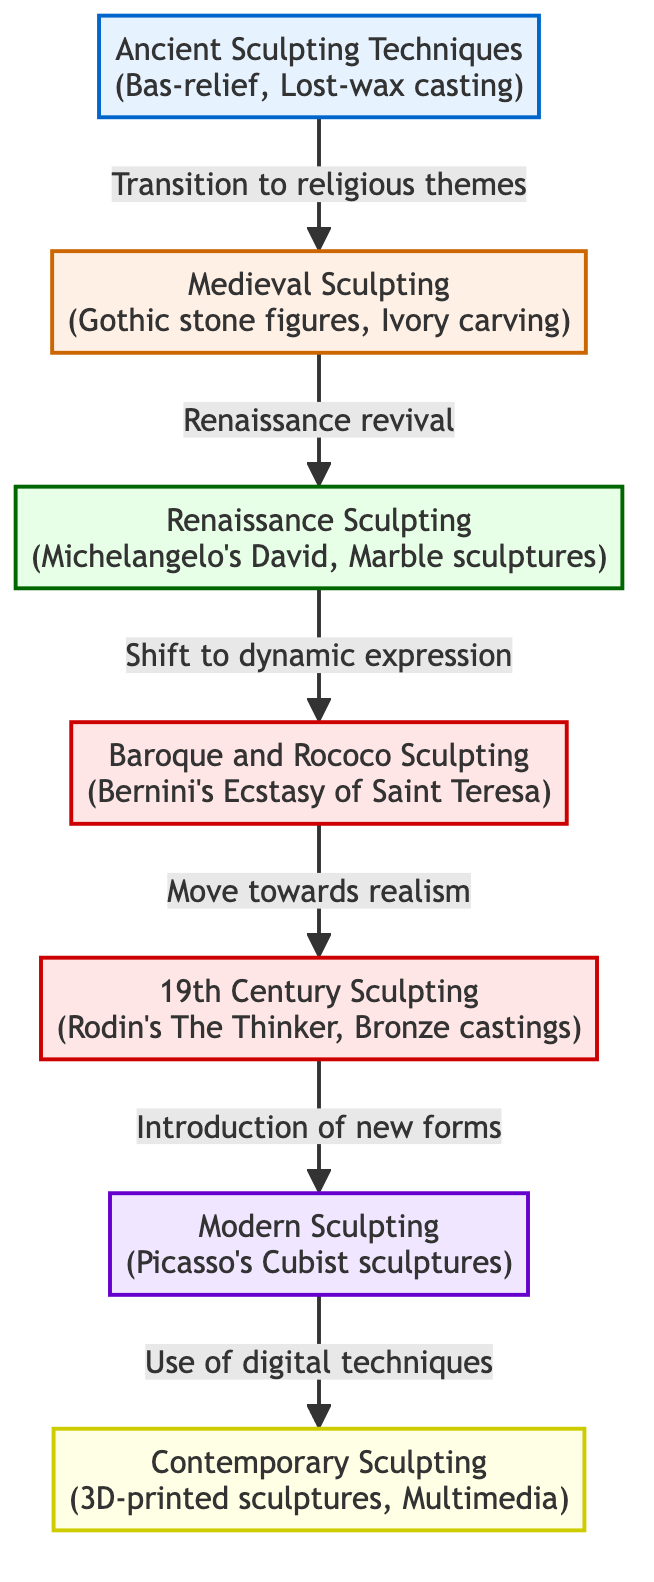What are the ancient sculpting techniques listed in the diagram? The diagram shows "Bas-relief" and "Lost-wax casting" under the ancient sculpting techniques node.
Answer: Bas-relief, Lost-wax casting Which sculpting technique is associated with Michelangelo? Michelangelo is prominently associated with "Michelangelo's David" under the Renaissance sculpting techniques.
Answer: Michelangelo's David How many distinct eras of sculpting techniques are included in the diagram? Counting each node from ancient, medieval, renaissance, baroque, modern, to contemporary, there are a total of 7 distinct eras listed.
Answer: 7 Which sculpting technique signifies the transition from Medieval to Renaissance? The transition is indicated by the phrase "Renaissance revival" connecting the nodes of Medieval and Renaissance sculpting.
Answer: Renaissance revival What is the last listed sculpting technique in the diagram? The final node in the diagram details "3D-printed sculptures, Multimedia" under contemporary sculpting.
Answer: 3D-printed sculptures, Multimedia Which connection signifies a shift towards realism? The connection labeled "Move towards realism" leads from Baroque and Rococo sculpting to 19th Century sculpting.
Answer: Move towards realism What is the characteristic technique of modern sculpting? The diagram attributes "Picasso's Cubist sculptures" as the defining characteristic of modern sculpting techniques.
Answer: Picasso's Cubist sculptures Which era introduced digital techniques in sculpting? The transition labeled "Use of digital techniques" leads from modern sculpting to contemporary sculpting, indicating the era that introduced digital techniques.
Answer: Use of digital techniques 